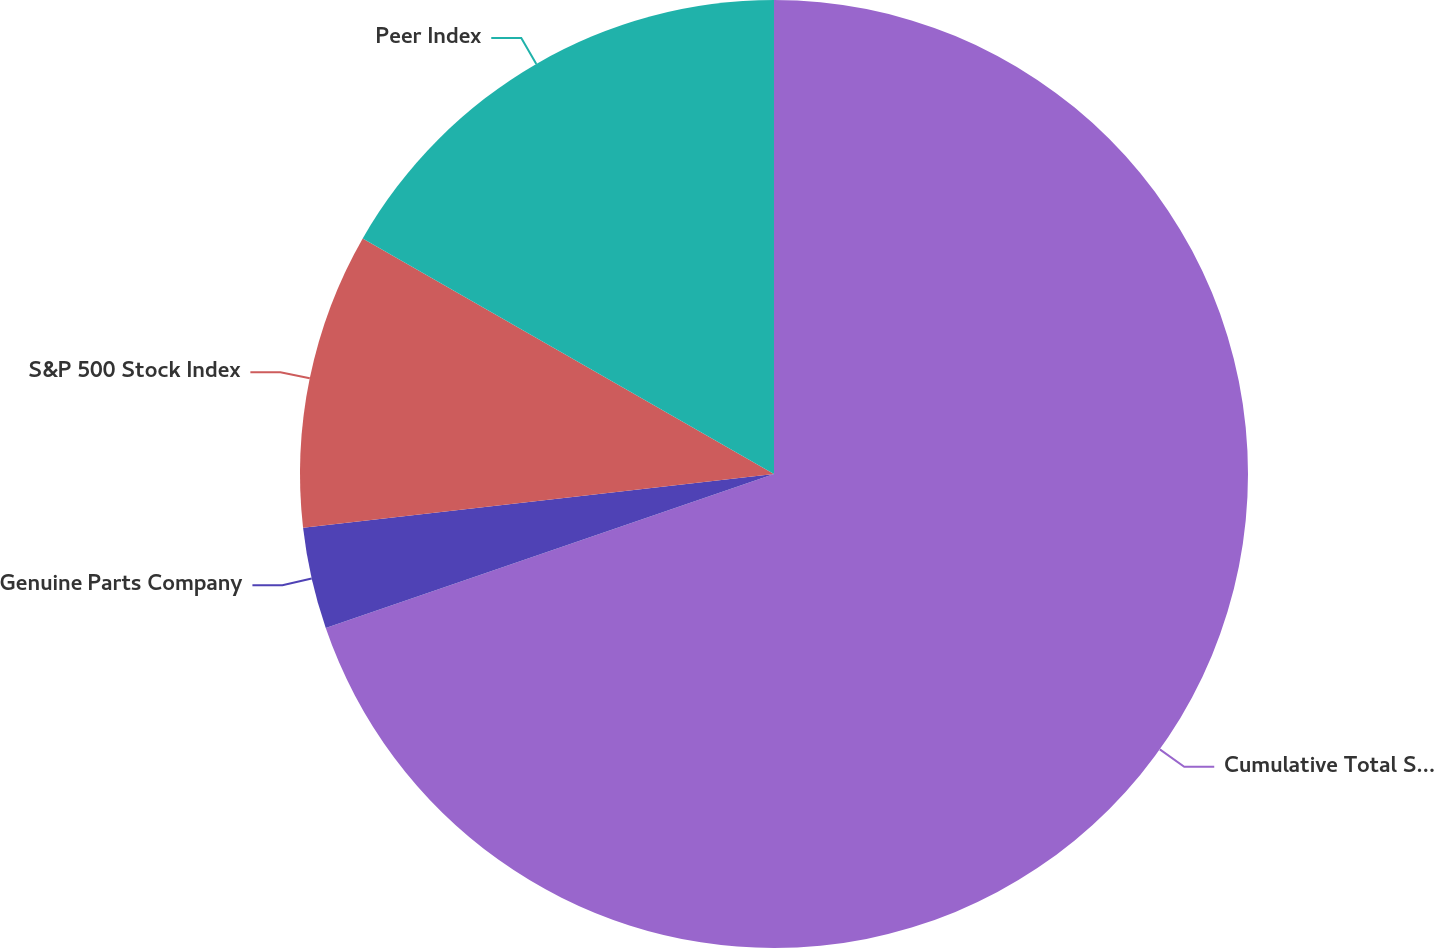<chart> <loc_0><loc_0><loc_500><loc_500><pie_chart><fcel>Cumulative Total Shareholder<fcel>Genuine Parts Company<fcel>S&P 500 Stock Index<fcel>Peer Index<nl><fcel>69.73%<fcel>3.46%<fcel>10.09%<fcel>16.72%<nl></chart> 